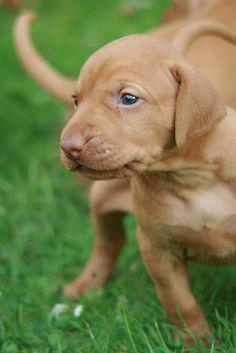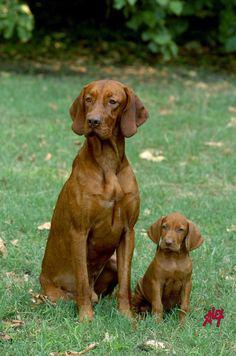The first image is the image on the left, the second image is the image on the right. For the images shown, is this caption "There are two dogs." true? Answer yes or no. No. The first image is the image on the left, the second image is the image on the right. Evaluate the accuracy of this statement regarding the images: "Each image includes at least one red-orange dog in a standing pose, at least two adult dogs in total are shown, and no other poses are shown.". Is it true? Answer yes or no. No. 